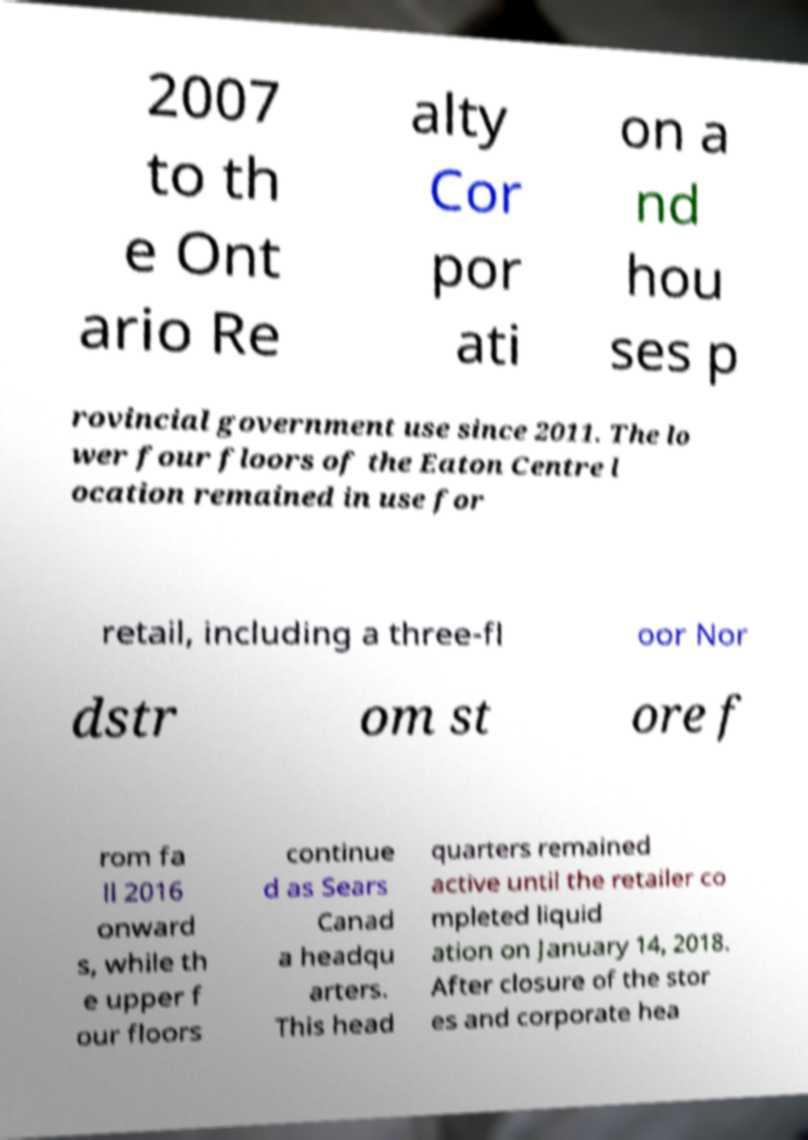Could you assist in decoding the text presented in this image and type it out clearly? 2007 to th e Ont ario Re alty Cor por ati on a nd hou ses p rovincial government use since 2011. The lo wer four floors of the Eaton Centre l ocation remained in use for retail, including a three-fl oor Nor dstr om st ore f rom fa ll 2016 onward s, while th e upper f our floors continue d as Sears Canad a headqu arters. This head quarters remained active until the retailer co mpleted liquid ation on January 14, 2018. After closure of the stor es and corporate hea 